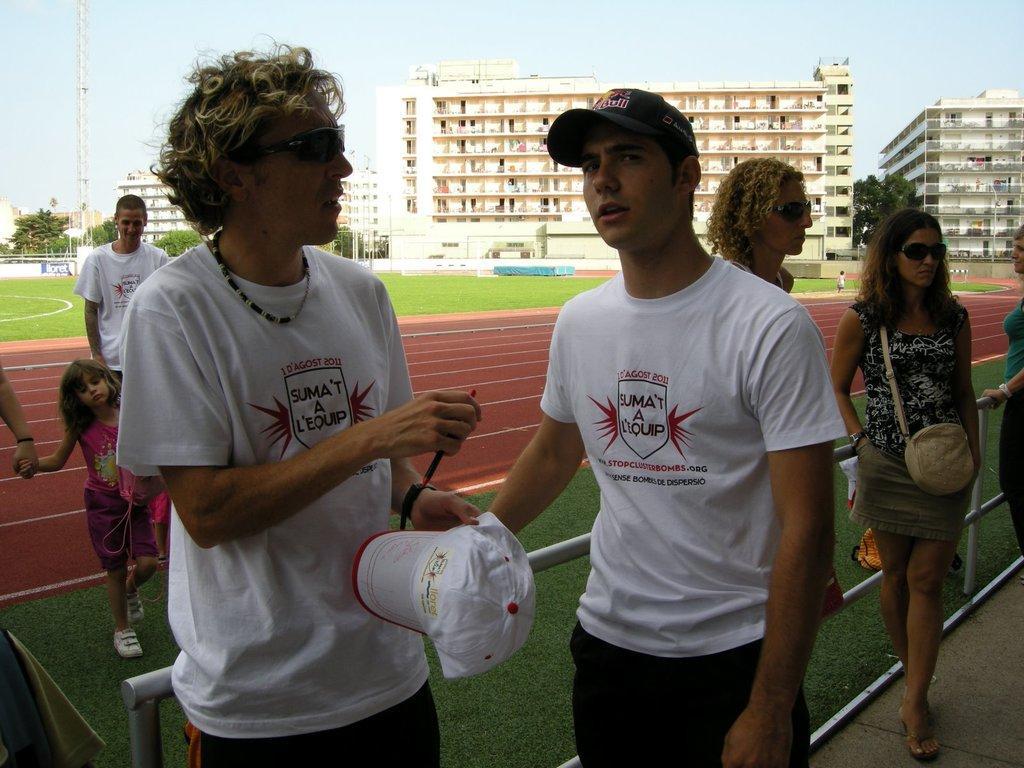Could you give a brief overview of what you see in this image? There are groups of people standing. These are the buildings. This looks like a stadium. In the background, I can see the trees. Here is a tower. This is the sky. 